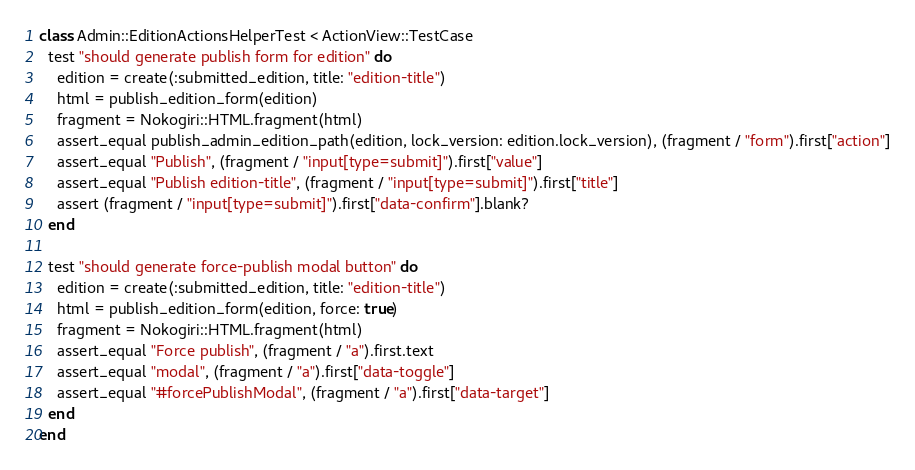Convert code to text. <code><loc_0><loc_0><loc_500><loc_500><_Ruby_>class Admin::EditionActionsHelperTest < ActionView::TestCase
  test "should generate publish form for edition" do
    edition = create(:submitted_edition, title: "edition-title")
    html = publish_edition_form(edition)
    fragment = Nokogiri::HTML.fragment(html)
    assert_equal publish_admin_edition_path(edition, lock_version: edition.lock_version), (fragment / "form").first["action"]
    assert_equal "Publish", (fragment / "input[type=submit]").first["value"]
    assert_equal "Publish edition-title", (fragment / "input[type=submit]").first["title"]
    assert (fragment / "input[type=submit]").first["data-confirm"].blank?
  end

  test "should generate force-publish modal button" do
    edition = create(:submitted_edition, title: "edition-title")
    html = publish_edition_form(edition, force: true)
    fragment = Nokogiri::HTML.fragment(html)
    assert_equal "Force publish", (fragment / "a").first.text
    assert_equal "modal", (fragment / "a").first["data-toggle"]
    assert_equal "#forcePublishModal", (fragment / "a").first["data-target"]
  end
end
</code> 